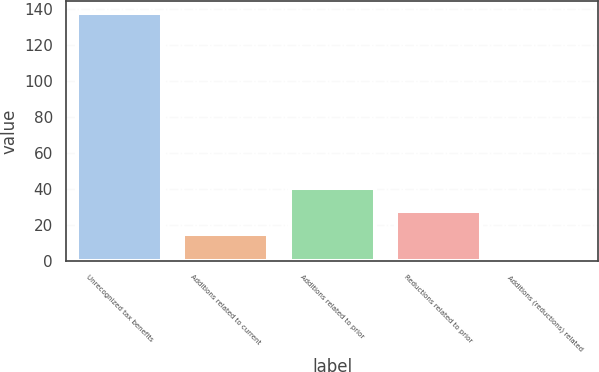Convert chart to OTSL. <chart><loc_0><loc_0><loc_500><loc_500><bar_chart><fcel>Unrecognized tax benefits<fcel>Additions related to current<fcel>Additions related to prior<fcel>Reductions related to prior<fcel>Additions (reductions) related<nl><fcel>137.67<fcel>14.97<fcel>40.31<fcel>27.64<fcel>2.3<nl></chart> 